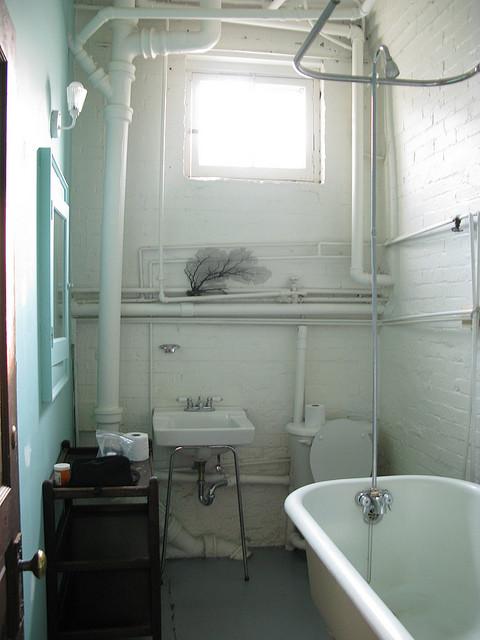What room is this?
Quick response, please. Bathroom. What is the main color of the bathroom?
Give a very brief answer. White. Is the bathtub shallow?
Quick response, please. No. 